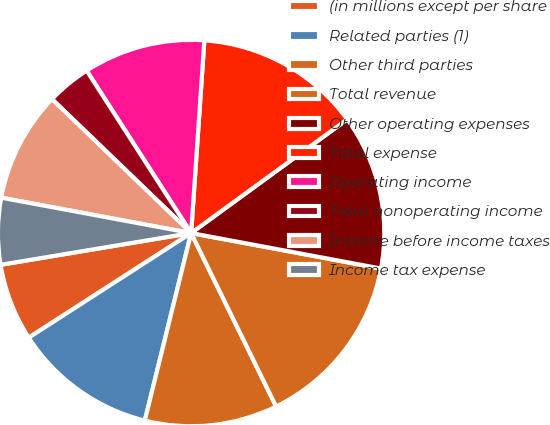Convert chart. <chart><loc_0><loc_0><loc_500><loc_500><pie_chart><fcel>(in millions except per share<fcel>Related parties (1)<fcel>Other third parties<fcel>Total revenue<fcel>Other operating expenses<fcel>Total expense<fcel>Operating income<fcel>Total nonoperating income<fcel>Income before income taxes<fcel>Income tax expense<nl><fcel>6.48%<fcel>12.04%<fcel>11.11%<fcel>14.81%<fcel>12.96%<fcel>13.89%<fcel>10.19%<fcel>3.71%<fcel>9.26%<fcel>5.56%<nl></chart> 